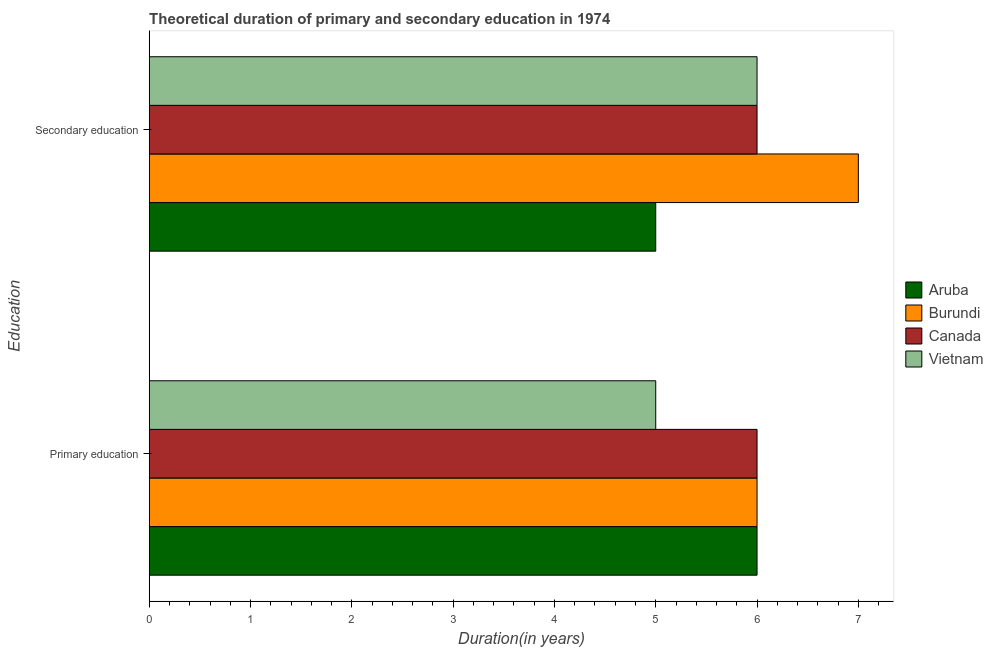How many different coloured bars are there?
Provide a short and direct response. 4. How many groups of bars are there?
Provide a short and direct response. 2. How many bars are there on the 1st tick from the bottom?
Make the answer very short. 4. Across all countries, what is the minimum duration of secondary education?
Your answer should be very brief. 5. In which country was the duration of primary education maximum?
Make the answer very short. Aruba. In which country was the duration of primary education minimum?
Offer a terse response. Vietnam. What is the total duration of primary education in the graph?
Your answer should be very brief. 23. What is the difference between the duration of secondary education in Canada and that in Aruba?
Ensure brevity in your answer.  1. What is the difference between the duration of secondary education in Canada and the duration of primary education in Aruba?
Offer a terse response. 0. What is the average duration of primary education per country?
Ensure brevity in your answer.  5.75. What is the difference between the duration of primary education and duration of secondary education in Vietnam?
Your answer should be very brief. -1. What is the ratio of the duration of primary education in Canada to that in Burundi?
Make the answer very short. 1. Is the duration of primary education in Aruba less than that in Vietnam?
Your response must be concise. No. In how many countries, is the duration of primary education greater than the average duration of primary education taken over all countries?
Keep it short and to the point. 3. What does the 1st bar from the top in Secondary education represents?
Offer a terse response. Vietnam. How many bars are there?
Provide a succinct answer. 8. Are all the bars in the graph horizontal?
Your response must be concise. Yes. How many countries are there in the graph?
Keep it short and to the point. 4. What is the difference between two consecutive major ticks on the X-axis?
Offer a terse response. 1. Are the values on the major ticks of X-axis written in scientific E-notation?
Make the answer very short. No. Does the graph contain any zero values?
Your answer should be very brief. No. What is the title of the graph?
Offer a terse response. Theoretical duration of primary and secondary education in 1974. Does "Tanzania" appear as one of the legend labels in the graph?
Offer a terse response. No. What is the label or title of the X-axis?
Give a very brief answer. Duration(in years). What is the label or title of the Y-axis?
Keep it short and to the point. Education. What is the Duration(in years) of Canada in Primary education?
Your answer should be very brief. 6. What is the Duration(in years) of Burundi in Secondary education?
Make the answer very short. 7. Across all Education, what is the maximum Duration(in years) in Aruba?
Ensure brevity in your answer.  6. Across all Education, what is the maximum Duration(in years) in Vietnam?
Your answer should be very brief. 6. Across all Education, what is the minimum Duration(in years) of Aruba?
Ensure brevity in your answer.  5. Across all Education, what is the minimum Duration(in years) in Canada?
Your response must be concise. 6. Across all Education, what is the minimum Duration(in years) of Vietnam?
Offer a very short reply. 5. What is the total Duration(in years) in Aruba in the graph?
Offer a very short reply. 11. What is the total Duration(in years) in Vietnam in the graph?
Your answer should be compact. 11. What is the difference between the Duration(in years) of Burundi in Primary education and that in Secondary education?
Make the answer very short. -1. What is the difference between the Duration(in years) in Vietnam in Primary education and that in Secondary education?
Offer a very short reply. -1. What is the difference between the Duration(in years) of Aruba in Primary education and the Duration(in years) of Canada in Secondary education?
Offer a terse response. 0. What is the difference between the Duration(in years) of Aruba in Primary education and the Duration(in years) of Vietnam in Secondary education?
Provide a short and direct response. 0. What is the difference between the Duration(in years) of Burundi in Primary education and the Duration(in years) of Canada in Secondary education?
Provide a succinct answer. 0. What is the difference between the Duration(in years) of Burundi in Primary education and the Duration(in years) of Vietnam in Secondary education?
Offer a terse response. 0. What is the average Duration(in years) of Aruba per Education?
Offer a very short reply. 5.5. What is the average Duration(in years) of Burundi per Education?
Ensure brevity in your answer.  6.5. What is the average Duration(in years) in Vietnam per Education?
Make the answer very short. 5.5. What is the difference between the Duration(in years) in Aruba and Duration(in years) in Burundi in Primary education?
Provide a succinct answer. 0. What is the difference between the Duration(in years) of Aruba and Duration(in years) of Vietnam in Primary education?
Offer a terse response. 1. What is the difference between the Duration(in years) of Burundi and Duration(in years) of Canada in Primary education?
Keep it short and to the point. 0. What is the difference between the Duration(in years) in Burundi and Duration(in years) in Vietnam in Primary education?
Your response must be concise. 1. What is the difference between the Duration(in years) in Burundi and Duration(in years) in Canada in Secondary education?
Offer a terse response. 1. What is the difference between the highest and the second highest Duration(in years) of Aruba?
Keep it short and to the point. 1. What is the difference between the highest and the second highest Duration(in years) of Burundi?
Provide a succinct answer. 1. What is the difference between the highest and the second highest Duration(in years) in Canada?
Make the answer very short. 0. What is the difference between the highest and the second highest Duration(in years) in Vietnam?
Your response must be concise. 1. What is the difference between the highest and the lowest Duration(in years) of Burundi?
Keep it short and to the point. 1. What is the difference between the highest and the lowest Duration(in years) of Canada?
Provide a short and direct response. 0. 